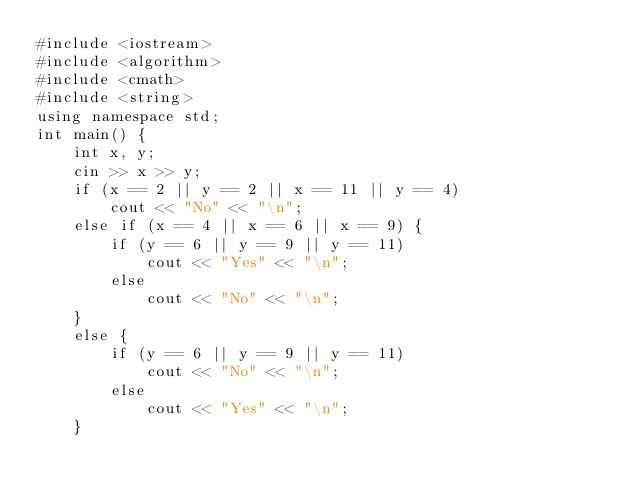<code> <loc_0><loc_0><loc_500><loc_500><_C++_>#include <iostream>
#include <algorithm>
#include <cmath>
#include <string>
using namespace std;
int main() {
	int x, y;
	cin >> x >> y;
	if (x == 2 || y == 2 || x == 11 || y == 4)
		cout << "No" << "\n";
	else if (x == 4 || x == 6 || x == 9) {
		if (y == 6 || y == 9 || y == 11)
			cout << "Yes" << "\n";
		else
			cout << "No" << "\n";
	}
	else {
		if (y == 6 || y == 9 || y == 11)
			cout << "No" << "\n";
		else
			cout << "Yes" << "\n";
	}</code> 